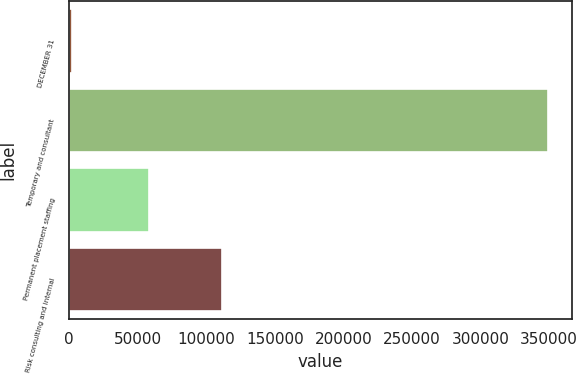Convert chart. <chart><loc_0><loc_0><loc_500><loc_500><bar_chart><fcel>DECEMBER 31<fcel>Temporary and consultant<fcel>Permanent placement staffing<fcel>Risk consulting and internal<nl><fcel>2008<fcel>348946<fcel>58538<fcel>111541<nl></chart> 